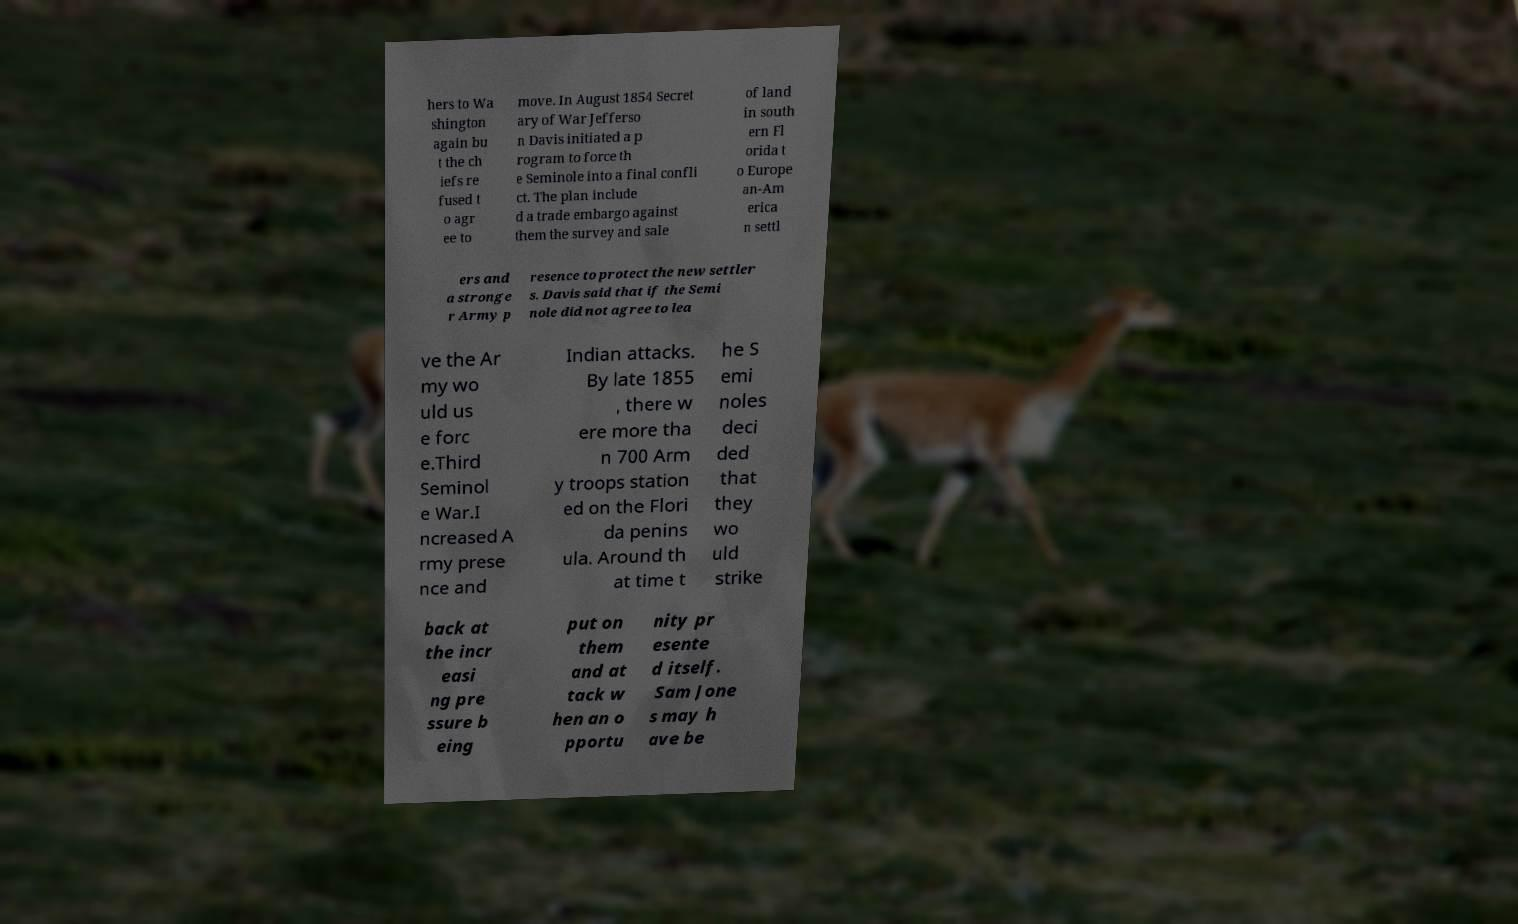Can you accurately transcribe the text from the provided image for me? hers to Wa shington again bu t the ch iefs re fused t o agr ee to move. In August 1854 Secret ary of War Jefferso n Davis initiated a p rogram to force th e Seminole into a final confli ct. The plan include d a trade embargo against them the survey and sale of land in south ern Fl orida t o Europe an-Am erica n settl ers and a stronge r Army p resence to protect the new settler s. Davis said that if the Semi nole did not agree to lea ve the Ar my wo uld us e forc e.Third Seminol e War.I ncreased A rmy prese nce and Indian attacks. By late 1855 , there w ere more tha n 700 Arm y troops station ed on the Flori da penins ula. Around th at time t he S emi noles deci ded that they wo uld strike back at the incr easi ng pre ssure b eing put on them and at tack w hen an o pportu nity pr esente d itself. Sam Jone s may h ave be 